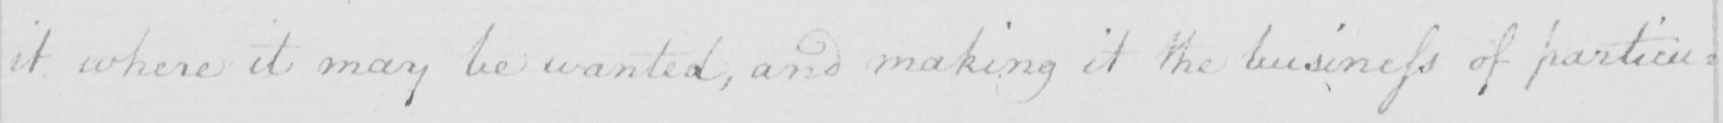Please provide the text content of this handwritten line. it where it may be wanted , and making it the business of particu= 